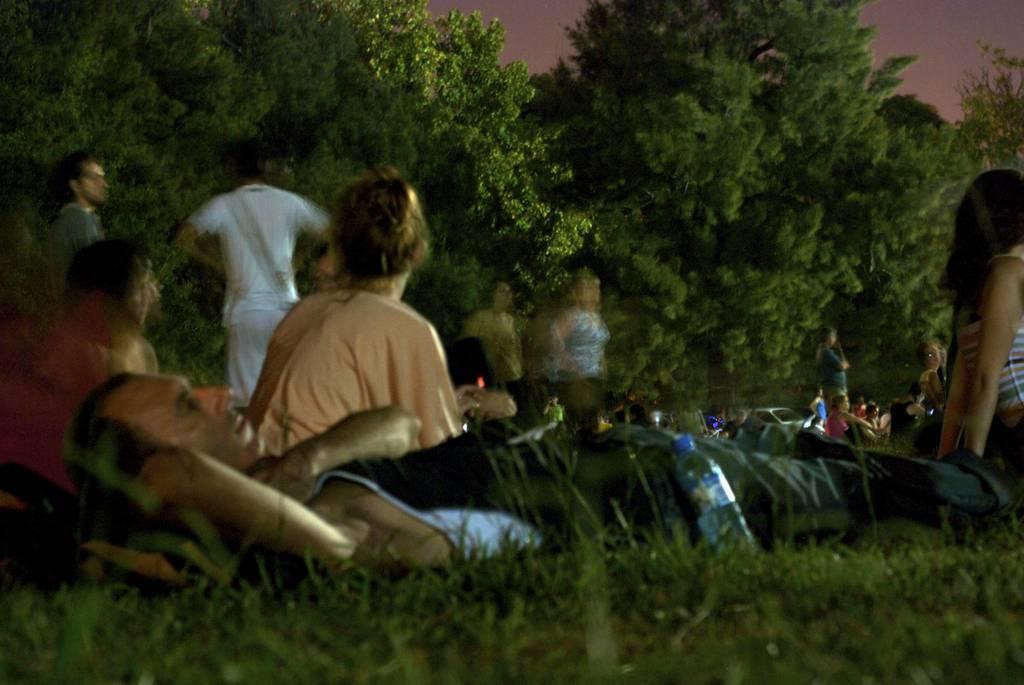How would you summarize this image in a sentence or two? In this image there are people sitting on a garden and a man is lying, in the background few people are standing and there are trees. 